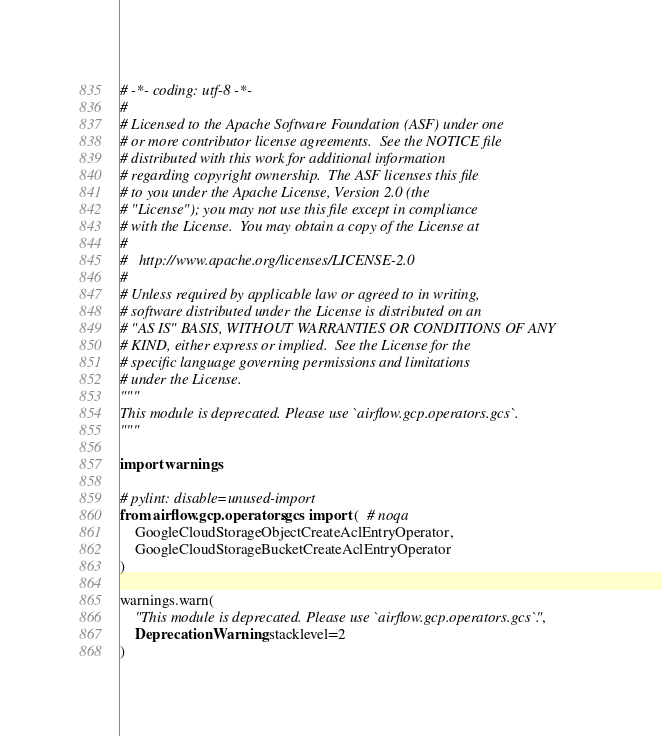<code> <loc_0><loc_0><loc_500><loc_500><_Python_># -*- coding: utf-8 -*-
#
# Licensed to the Apache Software Foundation (ASF) under one
# or more contributor license agreements.  See the NOTICE file
# distributed with this work for additional information
# regarding copyright ownership.  The ASF licenses this file
# to you under the Apache License, Version 2.0 (the
# "License"); you may not use this file except in compliance
# with the License.  You may obtain a copy of the License at
#
#   http://www.apache.org/licenses/LICENSE-2.0
#
# Unless required by applicable law or agreed to in writing,
# software distributed under the License is distributed on an
# "AS IS" BASIS, WITHOUT WARRANTIES OR CONDITIONS OF ANY
# KIND, either express or implied.  See the License for the
# specific language governing permissions and limitations
# under the License.
"""
This module is deprecated. Please use `airflow.gcp.operators.gcs`.
"""

import warnings

# pylint: disable=unused-import
from airflow.gcp.operators.gcs import (  # noqa
    GoogleCloudStorageObjectCreateAclEntryOperator,
    GoogleCloudStorageBucketCreateAclEntryOperator
)

warnings.warn(
    "This module is deprecated. Please use `airflow.gcp.operators.gcs`.",
    DeprecationWarning, stacklevel=2
)
</code> 